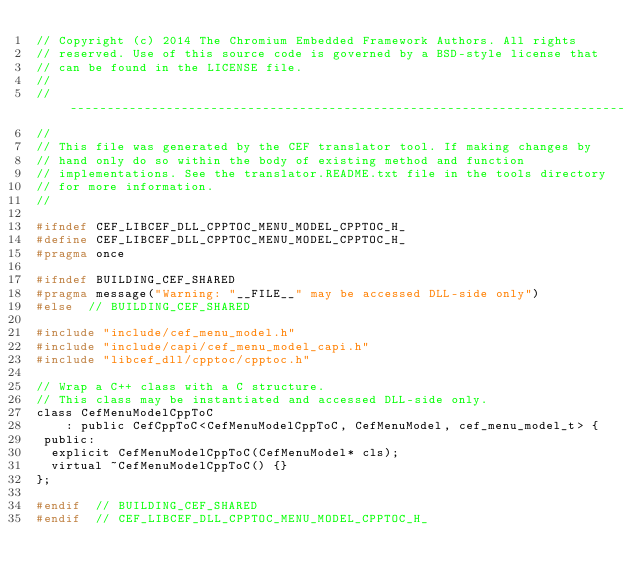Convert code to text. <code><loc_0><loc_0><loc_500><loc_500><_C_>// Copyright (c) 2014 The Chromium Embedded Framework Authors. All rights
// reserved. Use of this source code is governed by a BSD-style license that
// can be found in the LICENSE file.
//
// ---------------------------------------------------------------------------
//
// This file was generated by the CEF translator tool. If making changes by
// hand only do so within the body of existing method and function
// implementations. See the translator.README.txt file in the tools directory
// for more information.
//

#ifndef CEF_LIBCEF_DLL_CPPTOC_MENU_MODEL_CPPTOC_H_
#define CEF_LIBCEF_DLL_CPPTOC_MENU_MODEL_CPPTOC_H_
#pragma once

#ifndef BUILDING_CEF_SHARED
#pragma message("Warning: "__FILE__" may be accessed DLL-side only")
#else  // BUILDING_CEF_SHARED

#include "include/cef_menu_model.h"
#include "include/capi/cef_menu_model_capi.h"
#include "libcef_dll/cpptoc/cpptoc.h"

// Wrap a C++ class with a C structure.
// This class may be instantiated and accessed DLL-side only.
class CefMenuModelCppToC
    : public CefCppToC<CefMenuModelCppToC, CefMenuModel, cef_menu_model_t> {
 public:
  explicit CefMenuModelCppToC(CefMenuModel* cls);
  virtual ~CefMenuModelCppToC() {}
};

#endif  // BUILDING_CEF_SHARED
#endif  // CEF_LIBCEF_DLL_CPPTOC_MENU_MODEL_CPPTOC_H_

</code> 